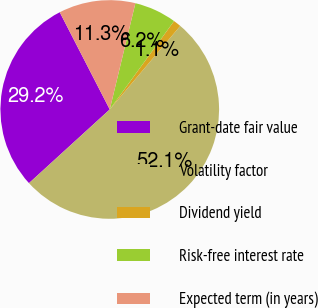Convert chart. <chart><loc_0><loc_0><loc_500><loc_500><pie_chart><fcel>Grant-date fair value<fcel>Volatility factor<fcel>Dividend yield<fcel>Risk-free interest rate<fcel>Expected term (in years)<nl><fcel>29.21%<fcel>52.07%<fcel>1.15%<fcel>6.24%<fcel>11.33%<nl></chart> 